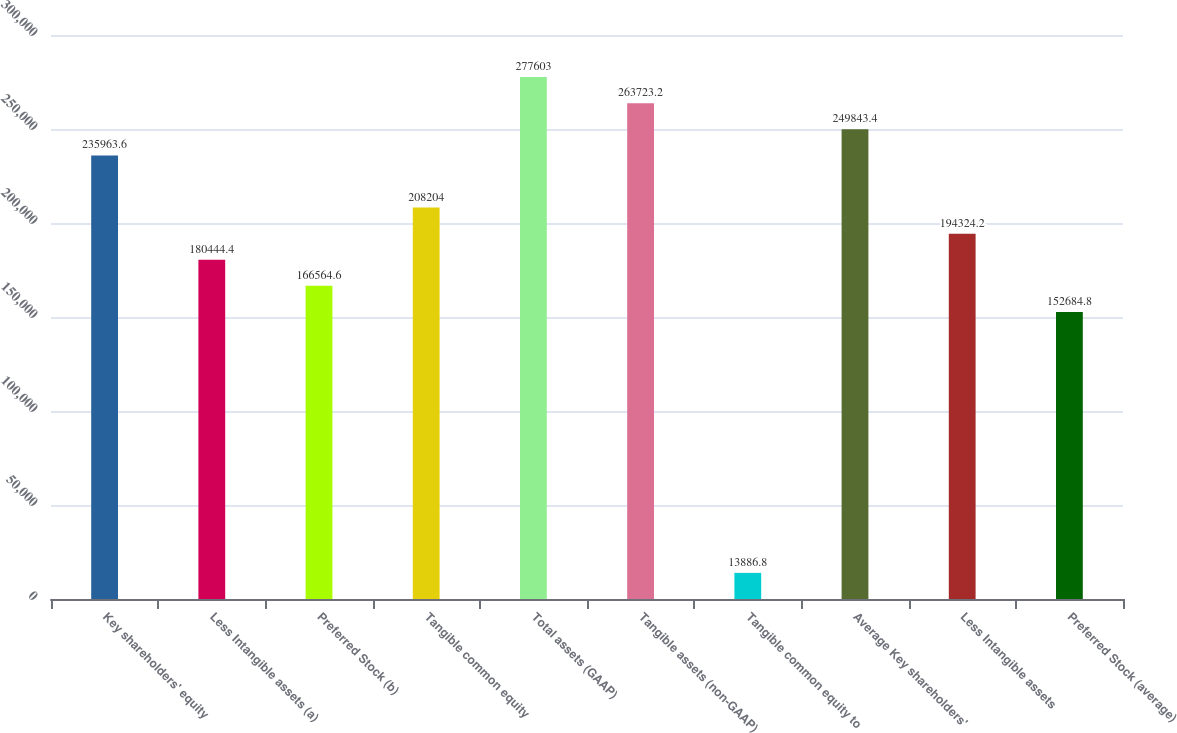<chart> <loc_0><loc_0><loc_500><loc_500><bar_chart><fcel>Key shareholders' equity<fcel>Less Intangible assets (a)<fcel>Preferred Stock (b)<fcel>Tangible common equity<fcel>Total assets (GAAP)<fcel>Tangible assets (non-GAAP)<fcel>Tangible common equity to<fcel>Average Key shareholders'<fcel>Less Intangible assets<fcel>Preferred Stock (average)<nl><fcel>235964<fcel>180444<fcel>166565<fcel>208204<fcel>277603<fcel>263723<fcel>13886.8<fcel>249843<fcel>194324<fcel>152685<nl></chart> 